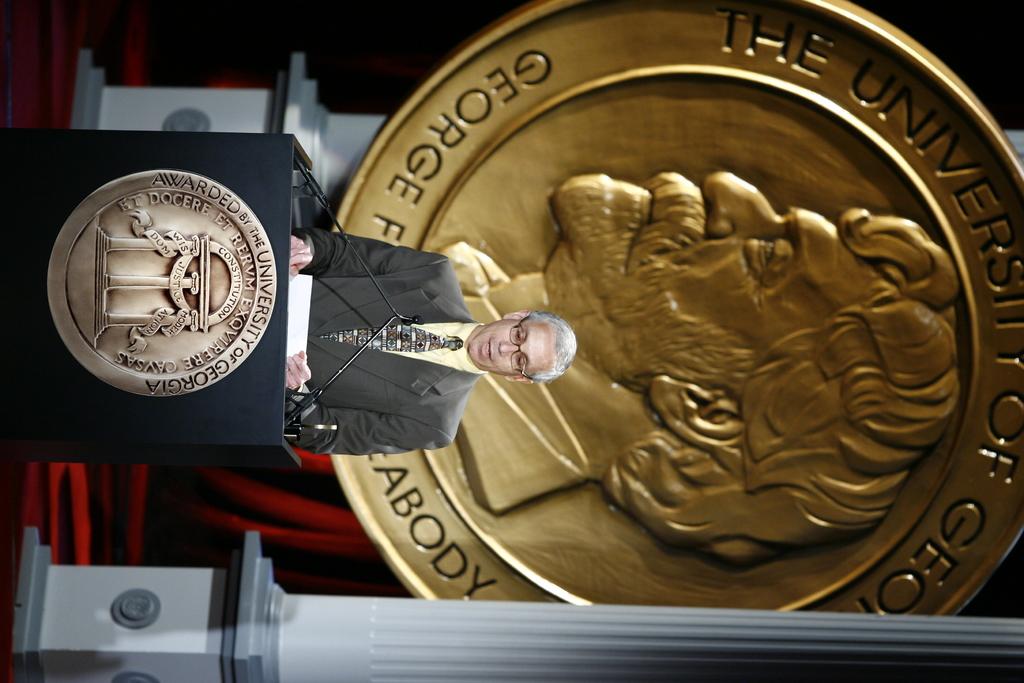What university is this speech taking place?
Give a very brief answer. University of georgia. Is this at a university?
Keep it short and to the point. Yes. 